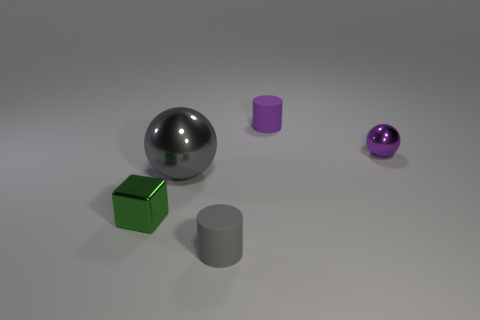There is a purple shiny sphere; does it have the same size as the gray metallic ball that is behind the small gray matte thing?
Your answer should be very brief. No. Is there a cylinder that has the same color as the tiny block?
Offer a very short reply. No. Is the material of the large gray thing the same as the small block?
Give a very brief answer. Yes. How many metallic objects are in front of the large gray thing?
Ensure brevity in your answer.  1. What is the material of the small thing that is behind the small green shiny block and on the left side of the tiny sphere?
Offer a very short reply. Rubber. What number of purple objects are the same size as the purple rubber cylinder?
Ensure brevity in your answer.  1. What color is the matte object on the right side of the small rubber cylinder in front of the purple cylinder?
Your response must be concise. Purple. Are any small blue shiny balls visible?
Offer a very short reply. No. Does the tiny purple matte thing have the same shape as the gray metallic thing?
Keep it short and to the point. No. What is the size of the other matte object that is the same color as the large thing?
Ensure brevity in your answer.  Small. 